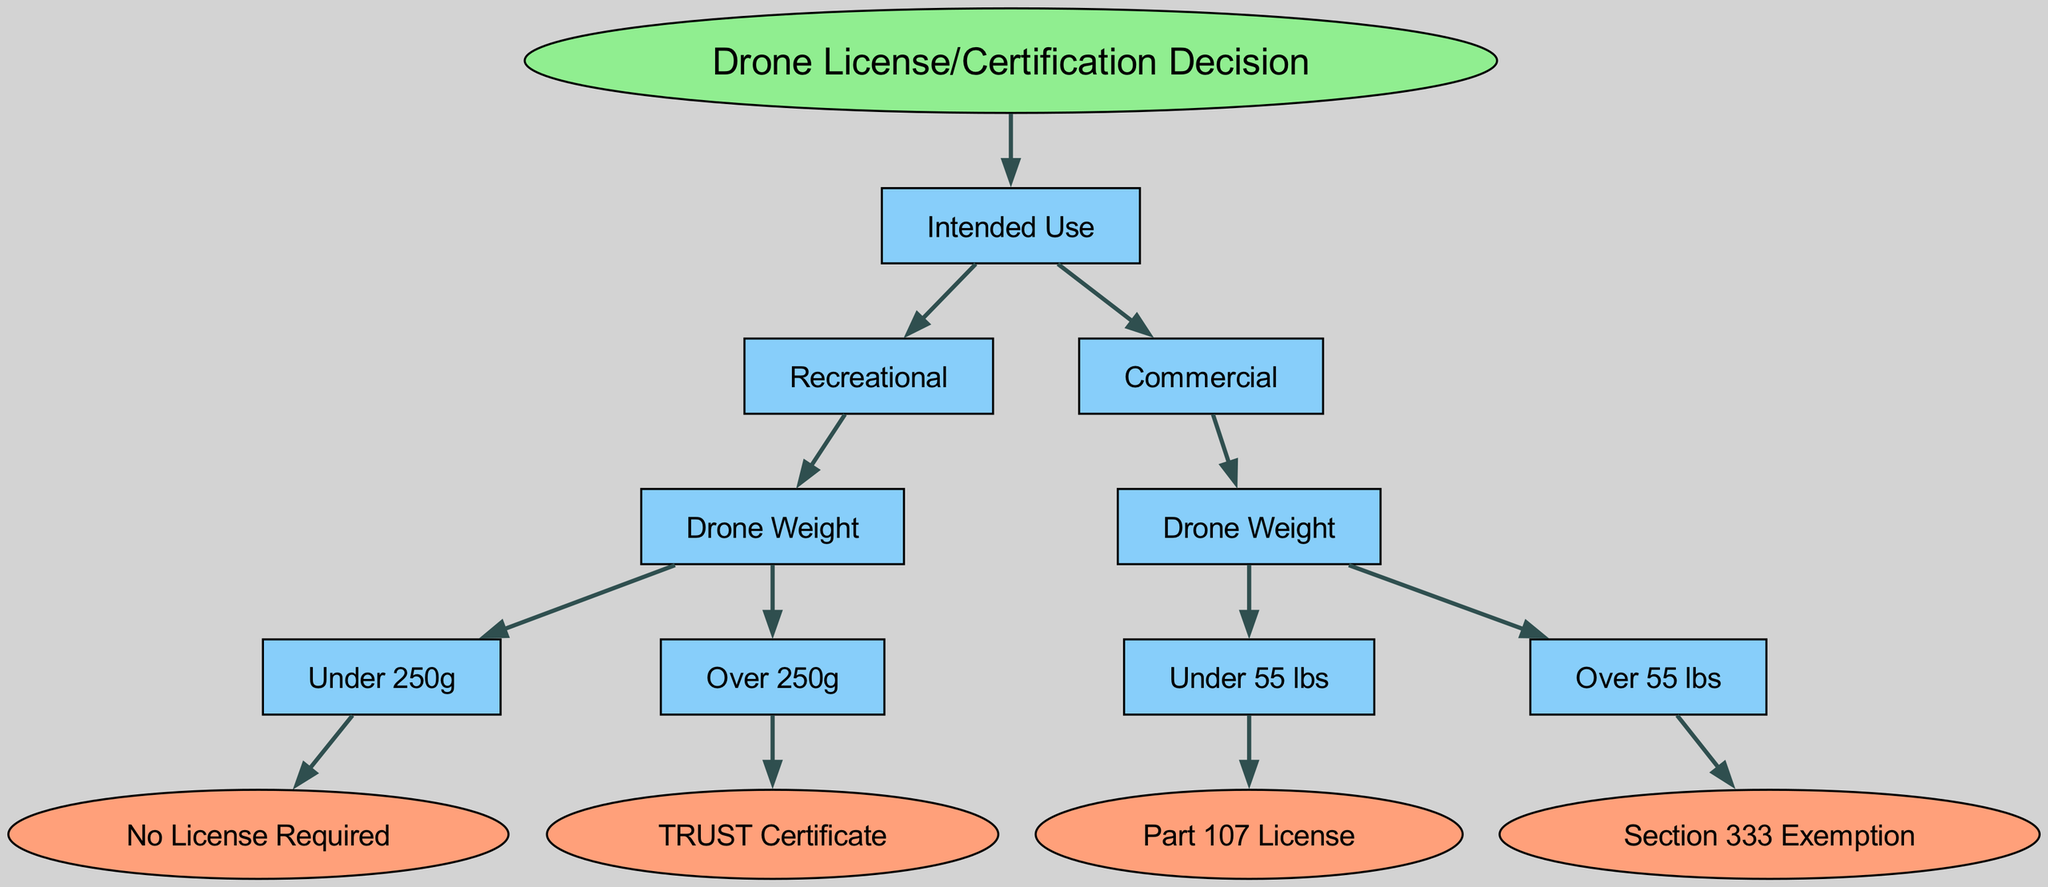What are the two main categories of intended use? The diagram branches out from the root node "Drone License/Certification Decision" into two main categories: "Recreational" and "Commercial." These categories represent different motivations for using drones, which inform the type of license or certification required.
Answer: Recreational, Commercial What is the license required for recreational drones over 250 grams? Following "Recreational" along with the branch for "Over 250g," the resultant requirement is the "TRUST Certificate." This means that for recreational use with a drone weighing more than 250 grams, this certificate is necessary.
Answer: TRUST Certificate How many types of licenses are needed for commercial drones under 55 lbs? The branch for "Commercial" and "Under 55 lbs" indicates that only "Part 107 License" is required in this category. Therefore, there is one type of license for commercial drones of this weight category.
Answer: 1 What is the exemption for commercial drones over 55 lbs? The "Over 55 lbs" branch under the "Commercial" category leads to the "Section 333 Exemption." This exemption is specifically noted in the decision tree as the licensing requirement for heavier commercial drones.
Answer: Section 333 Exemption If a drone weighs 200 grams and is used for recreation, is a license needed? According to the decision flow for "Recreational" use, with a weight of "Under 250g," the requirement leads to "No License Required." Hence, no certification is necessary for this scenario.
Answer: No License Required What happens if a drone weighs 70 lbs for commercial uses? In the decision tree, the branch for "Commercial" leads to "Over 55 lbs," which directs to "Section 333 Exemption." Therefore, any commercial drone above this weight will follow the exemption pathway.
Answer: Section 333 Exemption Is there any license for recreational drones that weigh 250 grams? The chart specifies that for drones under 250 grams, no license is required. However, it does not explicitly mention 250 grams; hence, the requirement remains "No License Required."
Answer: No License Required Which segment consists of the most weight categories listed? The decision tree indicates that under "Commercial," there are two weight categories ("Under 55 lbs" and "Over 55 lbs"). In contrast, "Recreational" has two weights as well but leads to fewer outcomes. Thus, "Commercial" has a more detailed weight range.
Answer: Commercial 